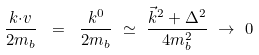Convert formula to latex. <formula><loc_0><loc_0><loc_500><loc_500>\frac { k { \cdot } v } { 2 m _ { b } } \ = \ \frac { k ^ { 0 } } { 2 m _ { b } } \ { \simeq } \ \frac { \vec { k } ^ { 2 } + { \Delta } ^ { 2 } } { 4 m _ { b } ^ { 2 } } \ { \rightarrow } \ 0</formula> 